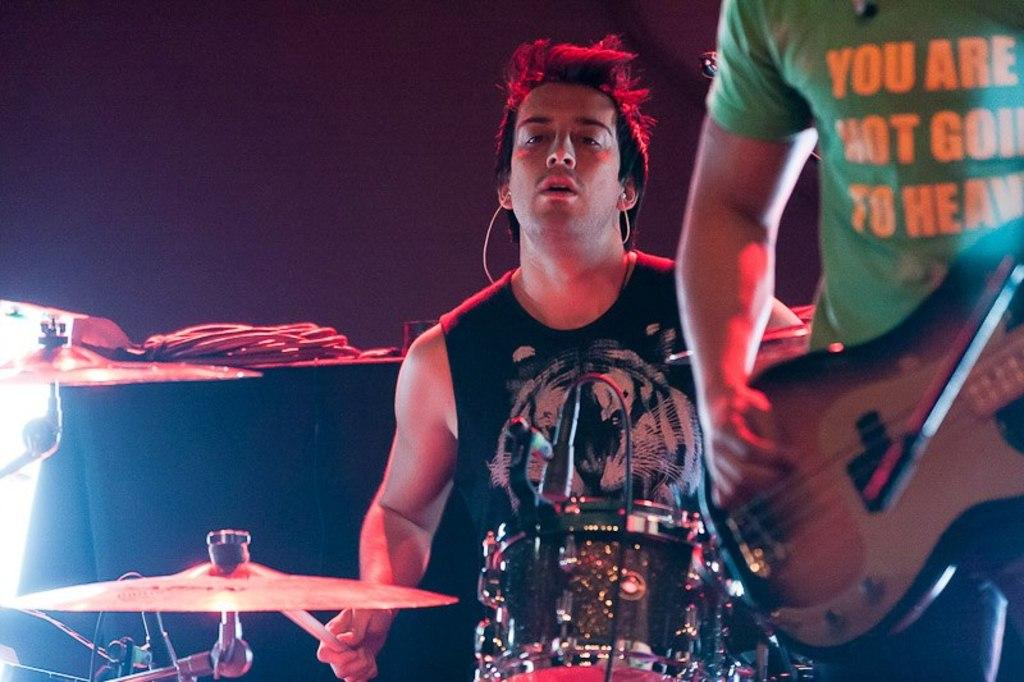How many people are present in the image? There are two people in the image. What are the two people doing in the image? The two people are playing musical instruments. What type of loaf is being served on the fork in the image? There is no loaf or fork present in the image; the two people are playing musical instruments. 